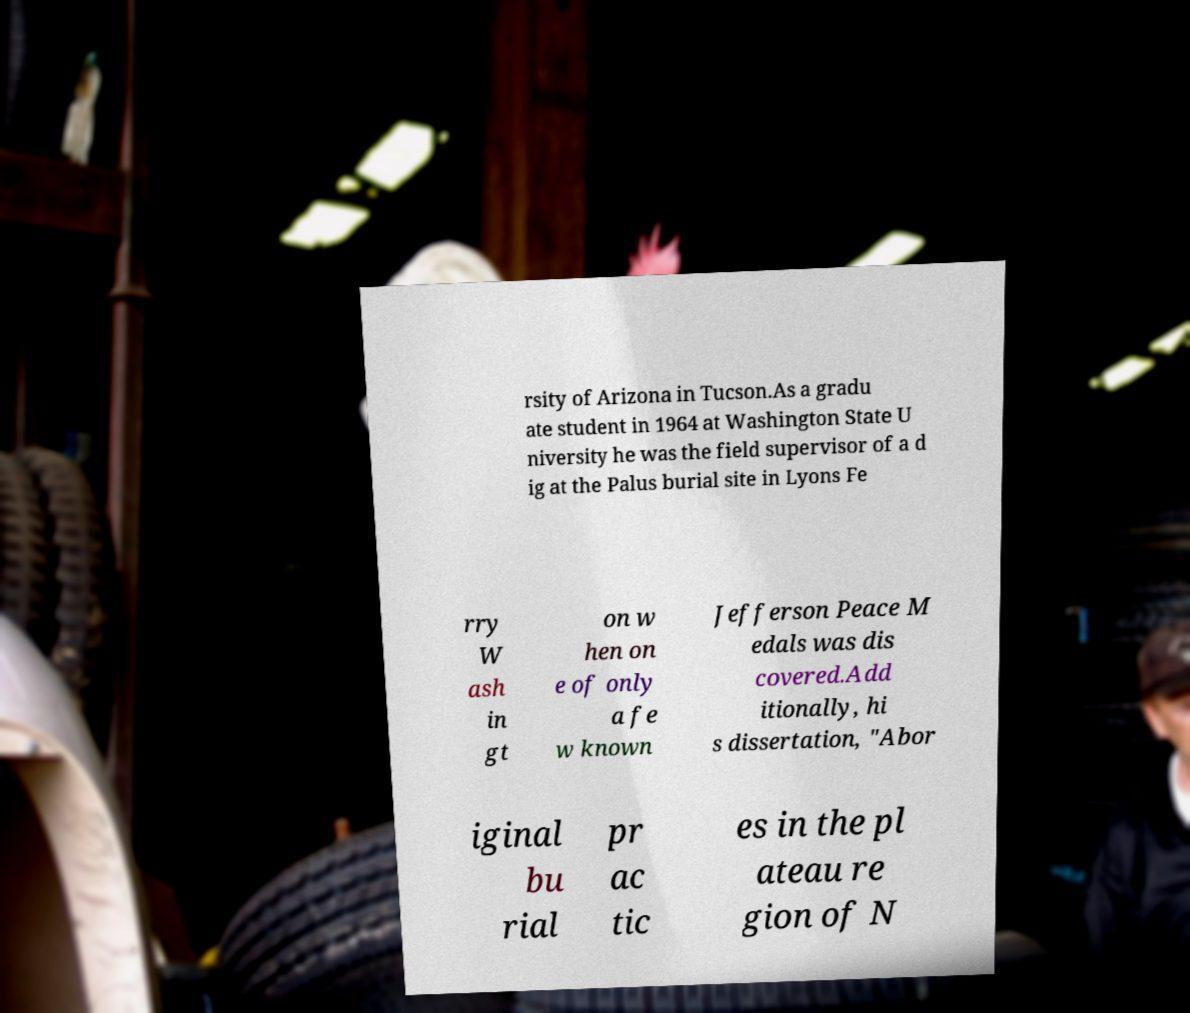Please identify and transcribe the text found in this image. rsity of Arizona in Tucson.As a gradu ate student in 1964 at Washington State U niversity he was the field supervisor of a d ig at the Palus burial site in Lyons Fe rry W ash in gt on w hen on e of only a fe w known Jefferson Peace M edals was dis covered.Add itionally, hi s dissertation, "Abor iginal bu rial pr ac tic es in the pl ateau re gion of N 